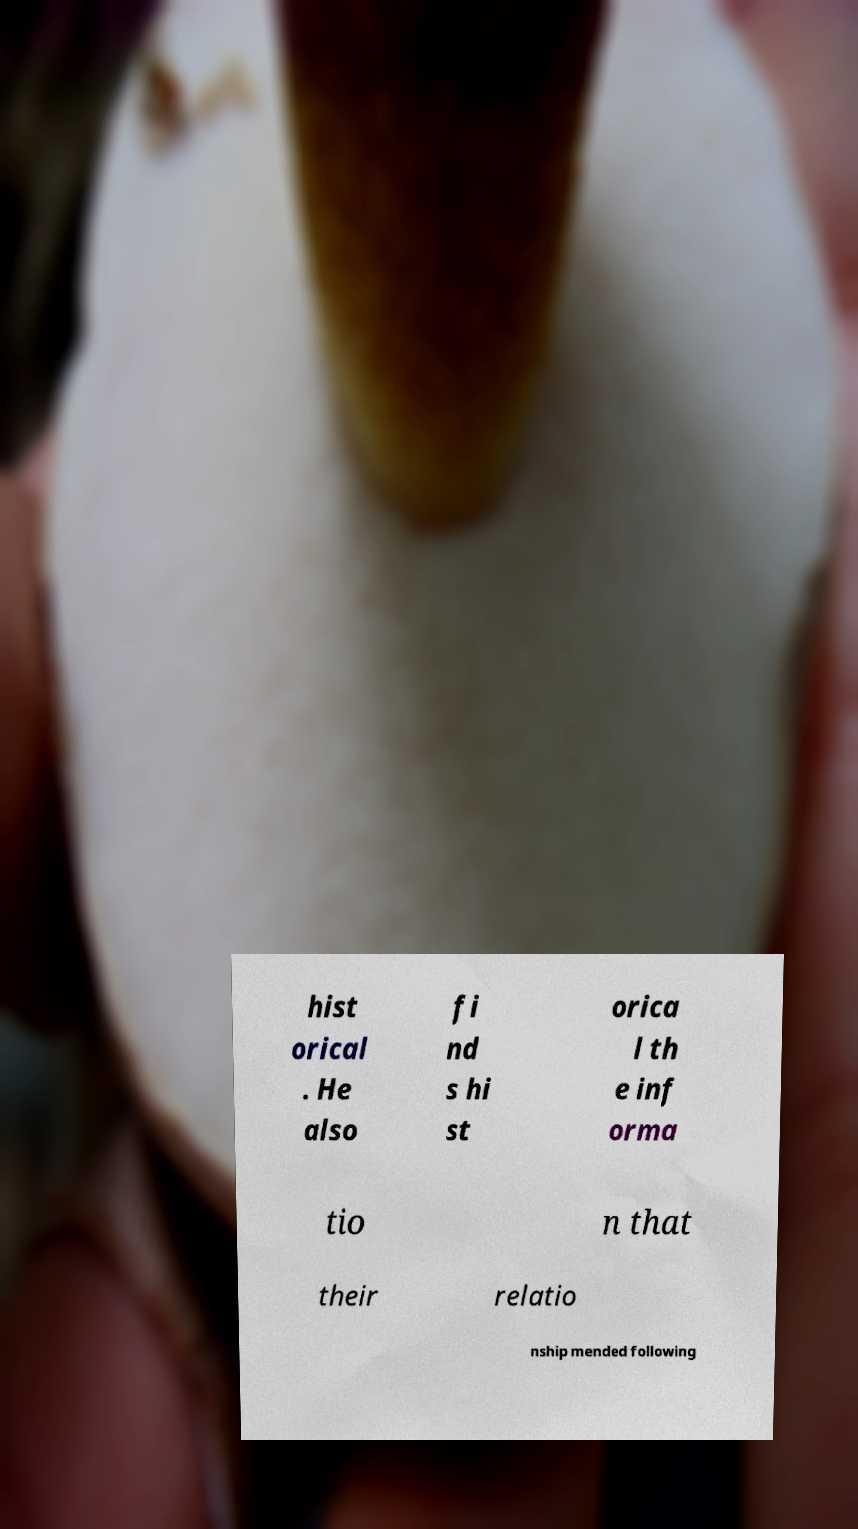Could you extract and type out the text from this image? hist orical . He also fi nd s hi st orica l th e inf orma tio n that their relatio nship mended following 